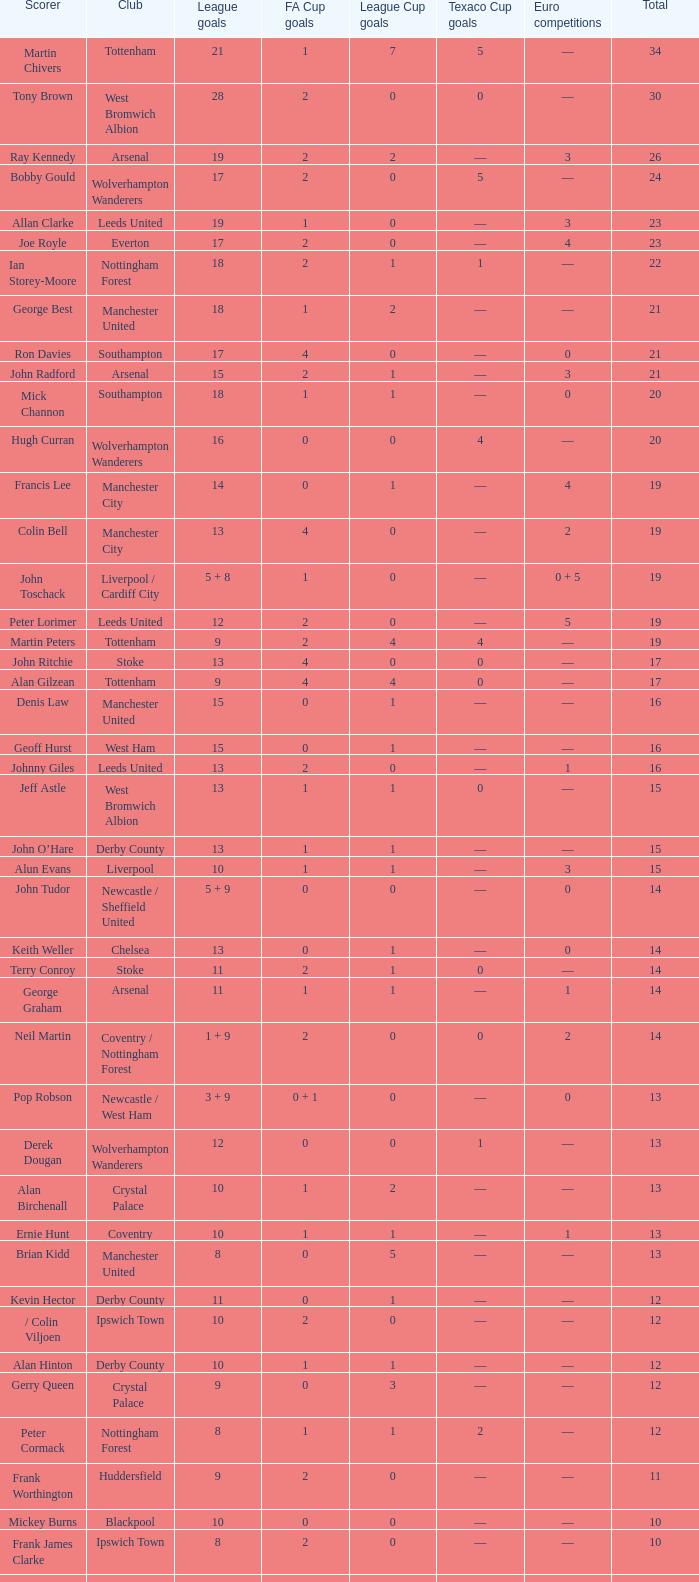What is FA Cup Goals, when Euro Competitions is 1, and when League Goals is 11? 1.0. Parse the full table. {'header': ['Scorer', 'Club', 'League goals', 'FA Cup goals', 'League Cup goals', 'Texaco Cup goals', 'Euro competitions', 'Total'], 'rows': [['Martin Chivers', 'Tottenham', '21', '1', '7', '5', '—', '34'], ['Tony Brown', 'West Bromwich Albion', '28', '2', '0', '0', '—', '30'], ['Ray Kennedy', 'Arsenal', '19', '2', '2', '—', '3', '26'], ['Bobby Gould', 'Wolverhampton Wanderers', '17', '2', '0', '5', '—', '24'], ['Allan Clarke', 'Leeds United', '19', '1', '0', '—', '3', '23'], ['Joe Royle', 'Everton', '17', '2', '0', '—', '4', '23'], ['Ian Storey-Moore', 'Nottingham Forest', '18', '2', '1', '1', '—', '22'], ['George Best', 'Manchester United', '18', '1', '2', '—', '—', '21'], ['Ron Davies', 'Southampton', '17', '4', '0', '—', '0', '21'], ['John Radford', 'Arsenal', '15', '2', '1', '—', '3', '21'], ['Mick Channon', 'Southampton', '18', '1', '1', '—', '0', '20'], ['Hugh Curran', 'Wolverhampton Wanderers', '16', '0', '0', '4', '—', '20'], ['Francis Lee', 'Manchester City', '14', '0', '1', '—', '4', '19'], ['Colin Bell', 'Manchester City', '13', '4', '0', '—', '2', '19'], ['John Toschack', 'Liverpool / Cardiff City', '5 + 8', '1', '0', '—', '0 + 5', '19'], ['Peter Lorimer', 'Leeds United', '12', '2', '0', '—', '5', '19'], ['Martin Peters', 'Tottenham', '9', '2', '4', '4', '—', '19'], ['John Ritchie', 'Stoke', '13', '4', '0', '0', '—', '17'], ['Alan Gilzean', 'Tottenham', '9', '4', '4', '0', '—', '17'], ['Denis Law', 'Manchester United', '15', '0', '1', '—', '—', '16'], ['Geoff Hurst', 'West Ham', '15', '0', '1', '—', '—', '16'], ['Johnny Giles', 'Leeds United', '13', '2', '0', '—', '1', '16'], ['Jeff Astle', 'West Bromwich Albion', '13', '1', '1', '0', '—', '15'], ['John O’Hare', 'Derby County', '13', '1', '1', '—', '—', '15'], ['Alun Evans', 'Liverpool', '10', '1', '1', '—', '3', '15'], ['John Tudor', 'Newcastle / Sheffield United', '5 + 9', '0', '0', '—', '0', '14'], ['Keith Weller', 'Chelsea', '13', '0', '1', '—', '0', '14'], ['Terry Conroy', 'Stoke', '11', '2', '1', '0', '—', '14'], ['George Graham', 'Arsenal', '11', '1', '1', '—', '1', '14'], ['Neil Martin', 'Coventry / Nottingham Forest', '1 + 9', '2', '0', '0', '2', '14'], ['Pop Robson', 'Newcastle / West Ham', '3 + 9', '0 + 1', '0', '—', '0', '13'], ['Derek Dougan', 'Wolverhampton Wanderers', '12', '0', '0', '1', '—', '13'], ['Alan Birchenall', 'Crystal Palace', '10', '1', '2', '—', '—', '13'], ['Ernie Hunt', 'Coventry', '10', '1', '1', '—', '1', '13'], ['Brian Kidd', 'Manchester United', '8', '0', '5', '—', '—', '13'], ['Kevin Hector', 'Derby County', '11', '0', '1', '—', '—', '12'], ['/ Colin Viljoen', 'Ipswich Town', '10', '2', '0', '—', '—', '12'], ['Alan Hinton', 'Derby County', '10', '1', '1', '—', '—', '12'], ['Gerry Queen', 'Crystal Palace', '9', '0', '3', '—', '—', '12'], ['Peter Cormack', 'Nottingham Forest', '8', '1', '1', '2', '—', '12'], ['Frank Worthington', 'Huddersfield', '9', '2', '0', '—', '—', '11'], ['Mickey Burns', 'Blackpool', '10', '0', '0', '—', '—', '10'], ['Frank James Clarke', 'Ipswich Town', '8', '2', '0', '—', '—', '10'], ['Jimmy Greenhoff', 'Stoke', '7', '3', '0', '0', '—', '10'], ['Charlie George', 'Arsenal', '5', '5', '0', '—', '0', '10']]} 